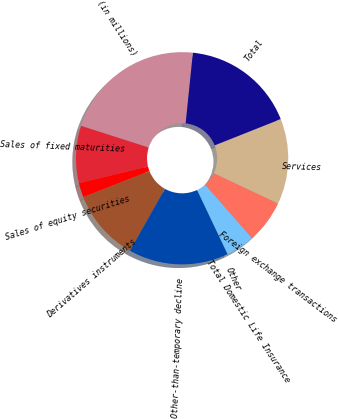<chart> <loc_0><loc_0><loc_500><loc_500><pie_chart><fcel>(in millions)<fcel>Sales of fixed maturities<fcel>Sales of equity securities<fcel>Derivatives instruments<fcel>Other-than-temporary decline<fcel>Other<fcel>Total Domestic Life Insurance<fcel>Foreign exchange transactions<fcel>Services<fcel>Total<nl><fcel>21.68%<fcel>8.7%<fcel>2.22%<fcel>10.86%<fcel>15.19%<fcel>0.05%<fcel>4.38%<fcel>6.54%<fcel>13.03%<fcel>17.35%<nl></chart> 